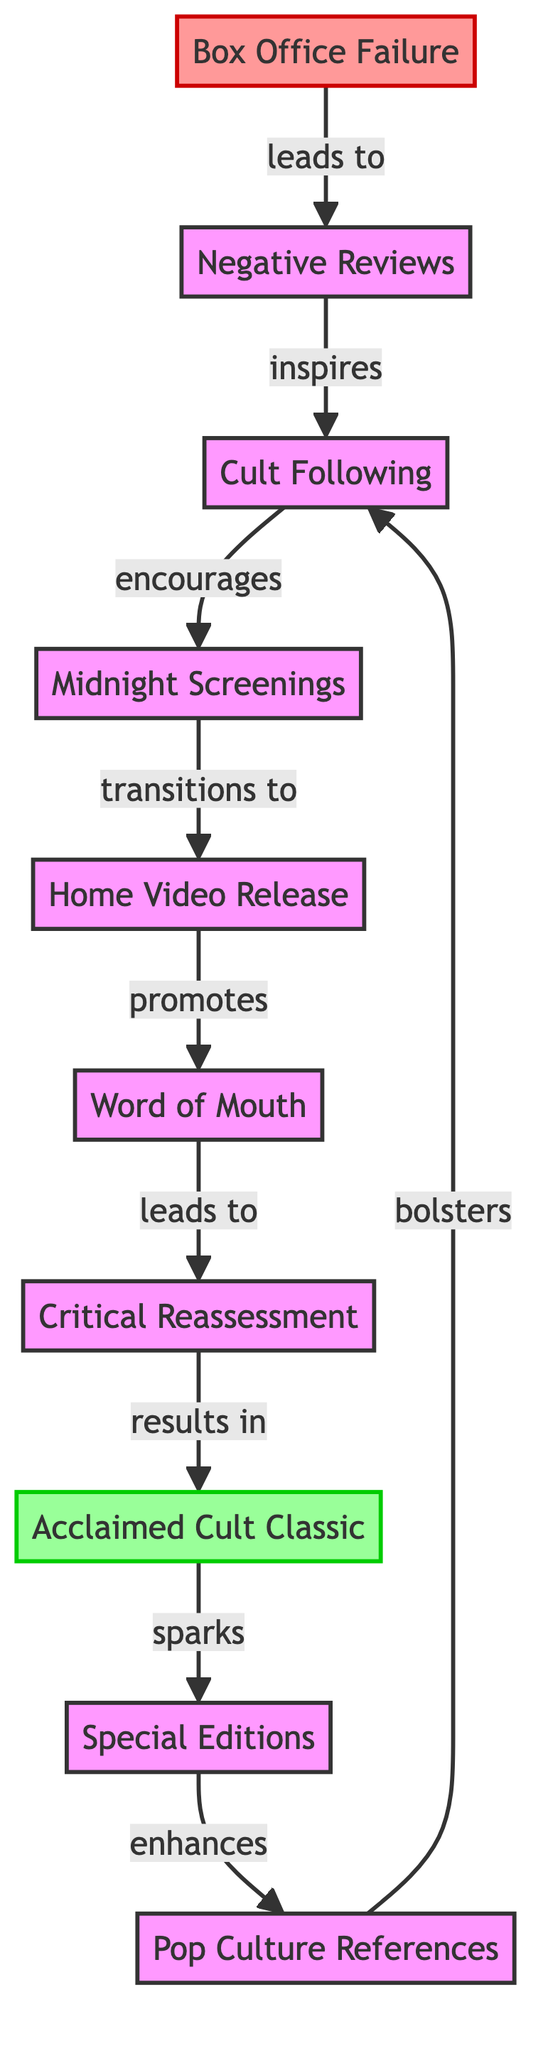What's the first node in the diagram? The first node listed on the diagram is "Box Office Failure," which represents the initial state of the film's release.
Answer: Box Office Failure How many nodes are there in total? Counting each unique entry in the diagram, including the starting and ending nodes, there are 10 distinct nodes in total.
Answer: 10 What relationship leads from "Negative Reviews" to "Cult Following"? The diagram shows that "Negative Reviews" inspires "Cult Following," indicating that despite poor reviews, a dedicated fanbase begins to form.
Answer: inspires Which node follows "Home Video Release"? The node that transitions directly from "Home Video Release" is "Word of Mouth," suggesting a progression in audience engagement after home media availability.
Answer: Word of Mouth What is the impact of "Special Editions" according to the graph? "Special Editions" enhances the "Pop Culture References," showing that these releases can increase the film's visibility and relevance in other media.
Answer: enhances How does "Word of Mouth" contribute to the evolution of the film? "Word of Mouth" leads to "Critical Reassessment," meaning as fans recommend the film, critics revisit and reassess its value, which plays a crucial role in a film's acceptance as a cult classic.
Answer: leads to What is the final destination of the flow in the diagram? The last node that concludes the flow of the diagram is "Acclaimed Cult Classic," which signifies the ultimate status achieved by the film after various transformative phases.
Answer: Acclaimed Cult Classic What event encourages the "Midnight Screenings"? The flow from "Cult Following" shows that this dedicated fanbase encourages "Midnight Screenings," which are special showings that can further propel interest and participation.
Answer: encourages What role does "Pop Culture References" play in relation to "Cult Following"? The graph indicates that "Pop Culture References" bolsters "Cult Following," meaning references in other media can strengthen the existing fanbase and attract new audiences.
Answer: bolsters 